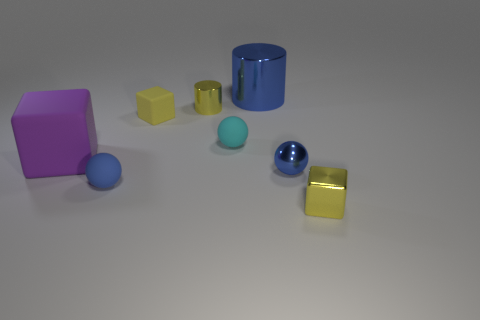Add 1 yellow rubber things. How many objects exist? 9 Subtract all spheres. How many objects are left? 5 Add 6 purple metal cylinders. How many purple metal cylinders exist? 6 Subtract 0 blue cubes. How many objects are left? 8 Subtract all tiny green rubber objects. Subtract all tiny blue matte spheres. How many objects are left? 7 Add 6 blue rubber spheres. How many blue rubber spheres are left? 7 